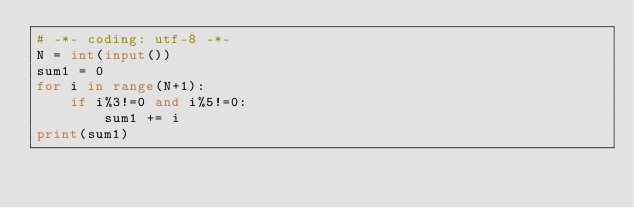<code> <loc_0><loc_0><loc_500><loc_500><_Python_># -*- coding: utf-8 -*-
N = int(input())
sum1 = 0
for i in range(N+1):
    if i%3!=0 and i%5!=0:
        sum1 += i
print(sum1)</code> 